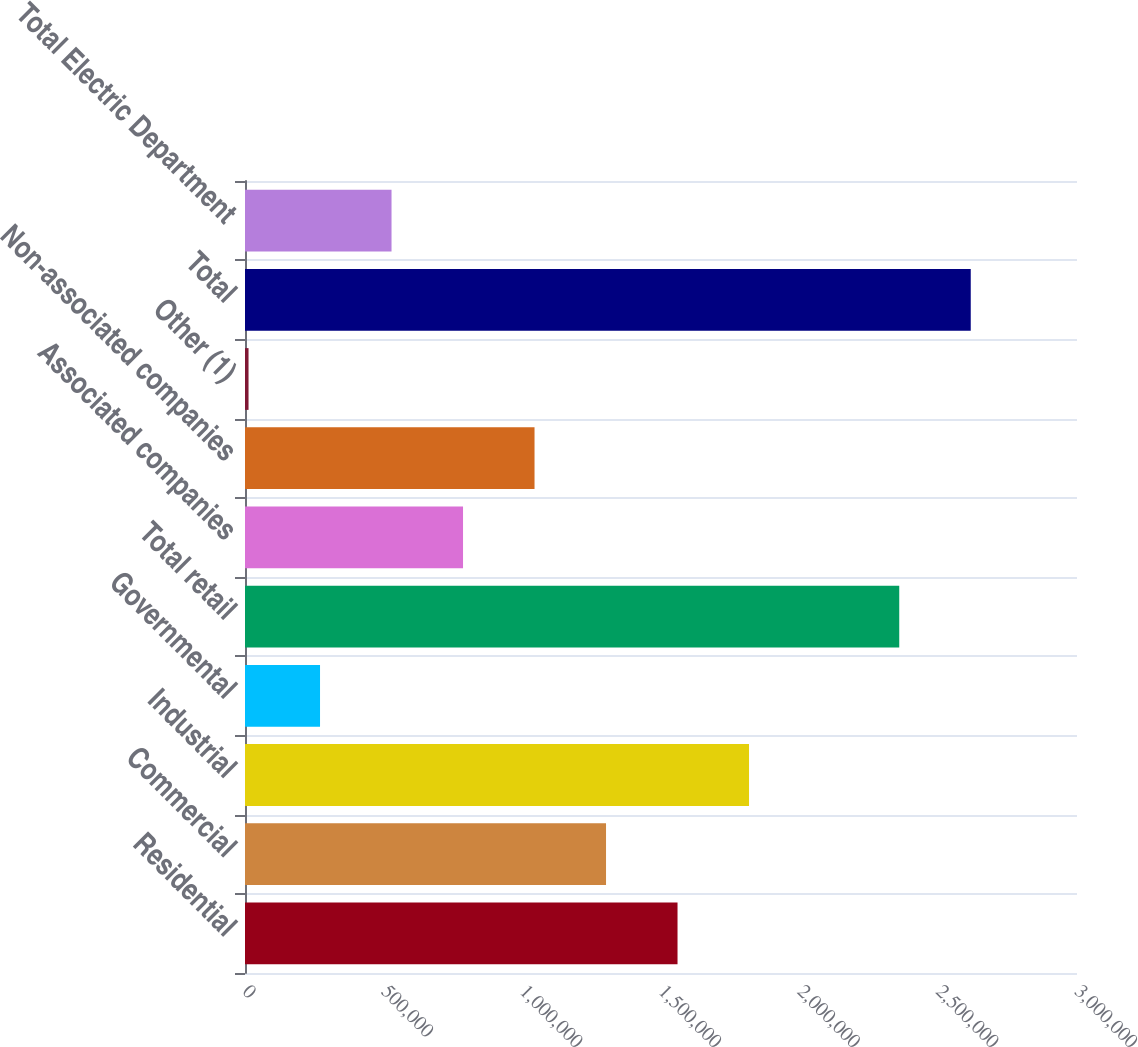Convert chart to OTSL. <chart><loc_0><loc_0><loc_500><loc_500><bar_chart><fcel>Residential<fcel>Commercial<fcel>Industrial<fcel>Governmental<fcel>Total retail<fcel>Associated companies<fcel>Non-associated companies<fcel>Other (1)<fcel>Total<fcel>Total Electric Department<nl><fcel>1.55959e+06<fcel>1.30178e+06<fcel>1.8174e+06<fcel>270538<fcel>2.35906e+06<fcel>786160<fcel>1.04397e+06<fcel>12727<fcel>2.61687e+06<fcel>528349<nl></chart> 